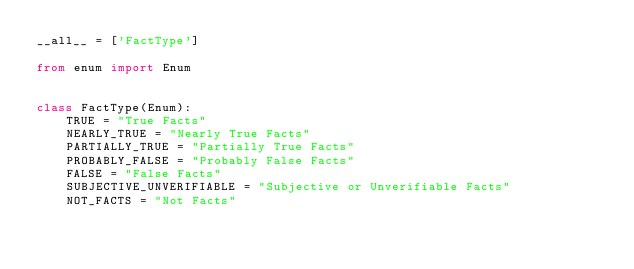<code> <loc_0><loc_0><loc_500><loc_500><_Python_>__all__ = ['FactType']

from enum import Enum


class FactType(Enum):
	TRUE = "True Facts"
	NEARLY_TRUE = "Nearly True Facts"
	PARTIALLY_TRUE = "Partially True Facts"
	PROBABLY_FALSE = "Probably False Facts"
	FALSE = "False Facts"
	SUBJECTIVE_UNVERIFIABLE = "Subjective or Unverifiable Facts"
	NOT_FACTS = "Not Facts"
</code> 